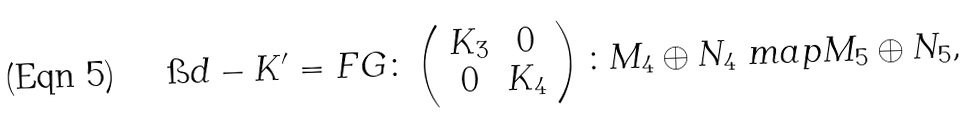<formula> <loc_0><loc_0><loc_500><loc_500>\i d - K ^ { \prime } = F G \colon \left ( \begin{array} { c c } K _ { 3 } & 0 \\ 0 & K _ { 4 } \end{array} \right ) \colon M _ { 4 } \oplus N _ { 4 } \ m a p M _ { 5 } \oplus N _ { 5 } ,</formula> 